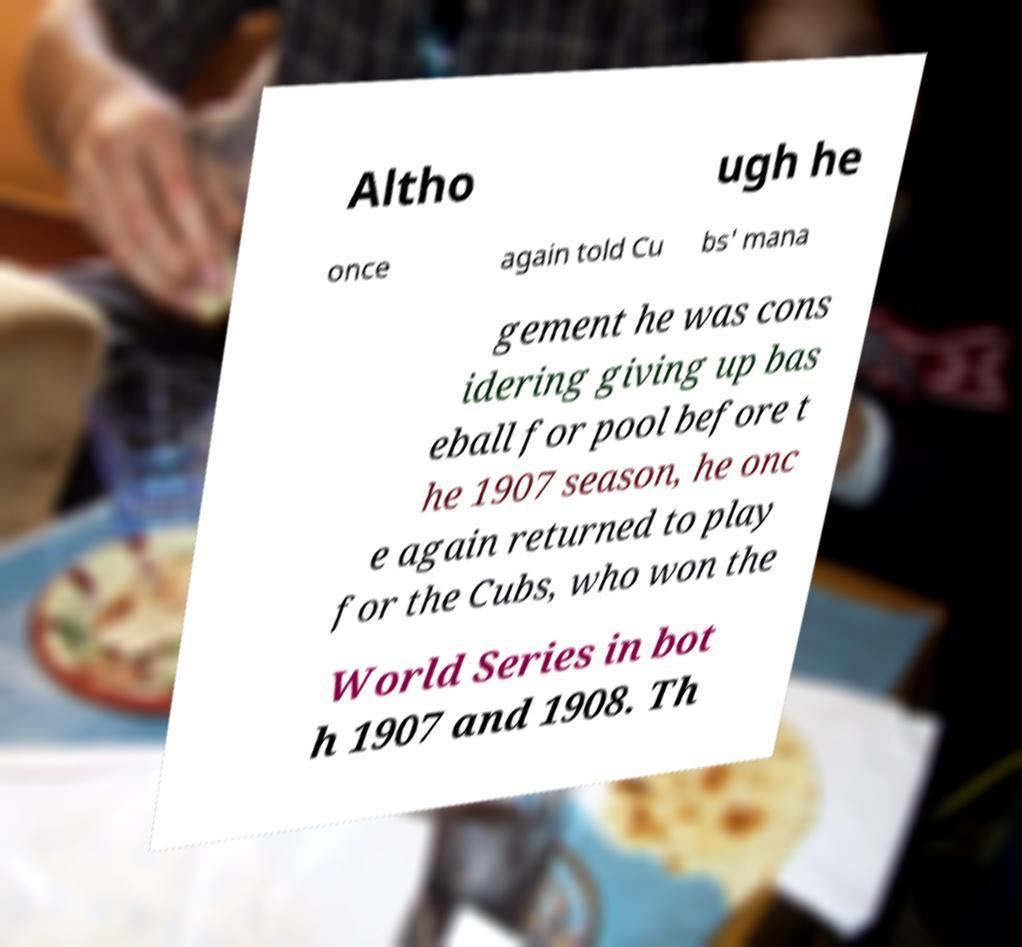For documentation purposes, I need the text within this image transcribed. Could you provide that? Altho ugh he once again told Cu bs' mana gement he was cons idering giving up bas eball for pool before t he 1907 season, he onc e again returned to play for the Cubs, who won the World Series in bot h 1907 and 1908. Th 